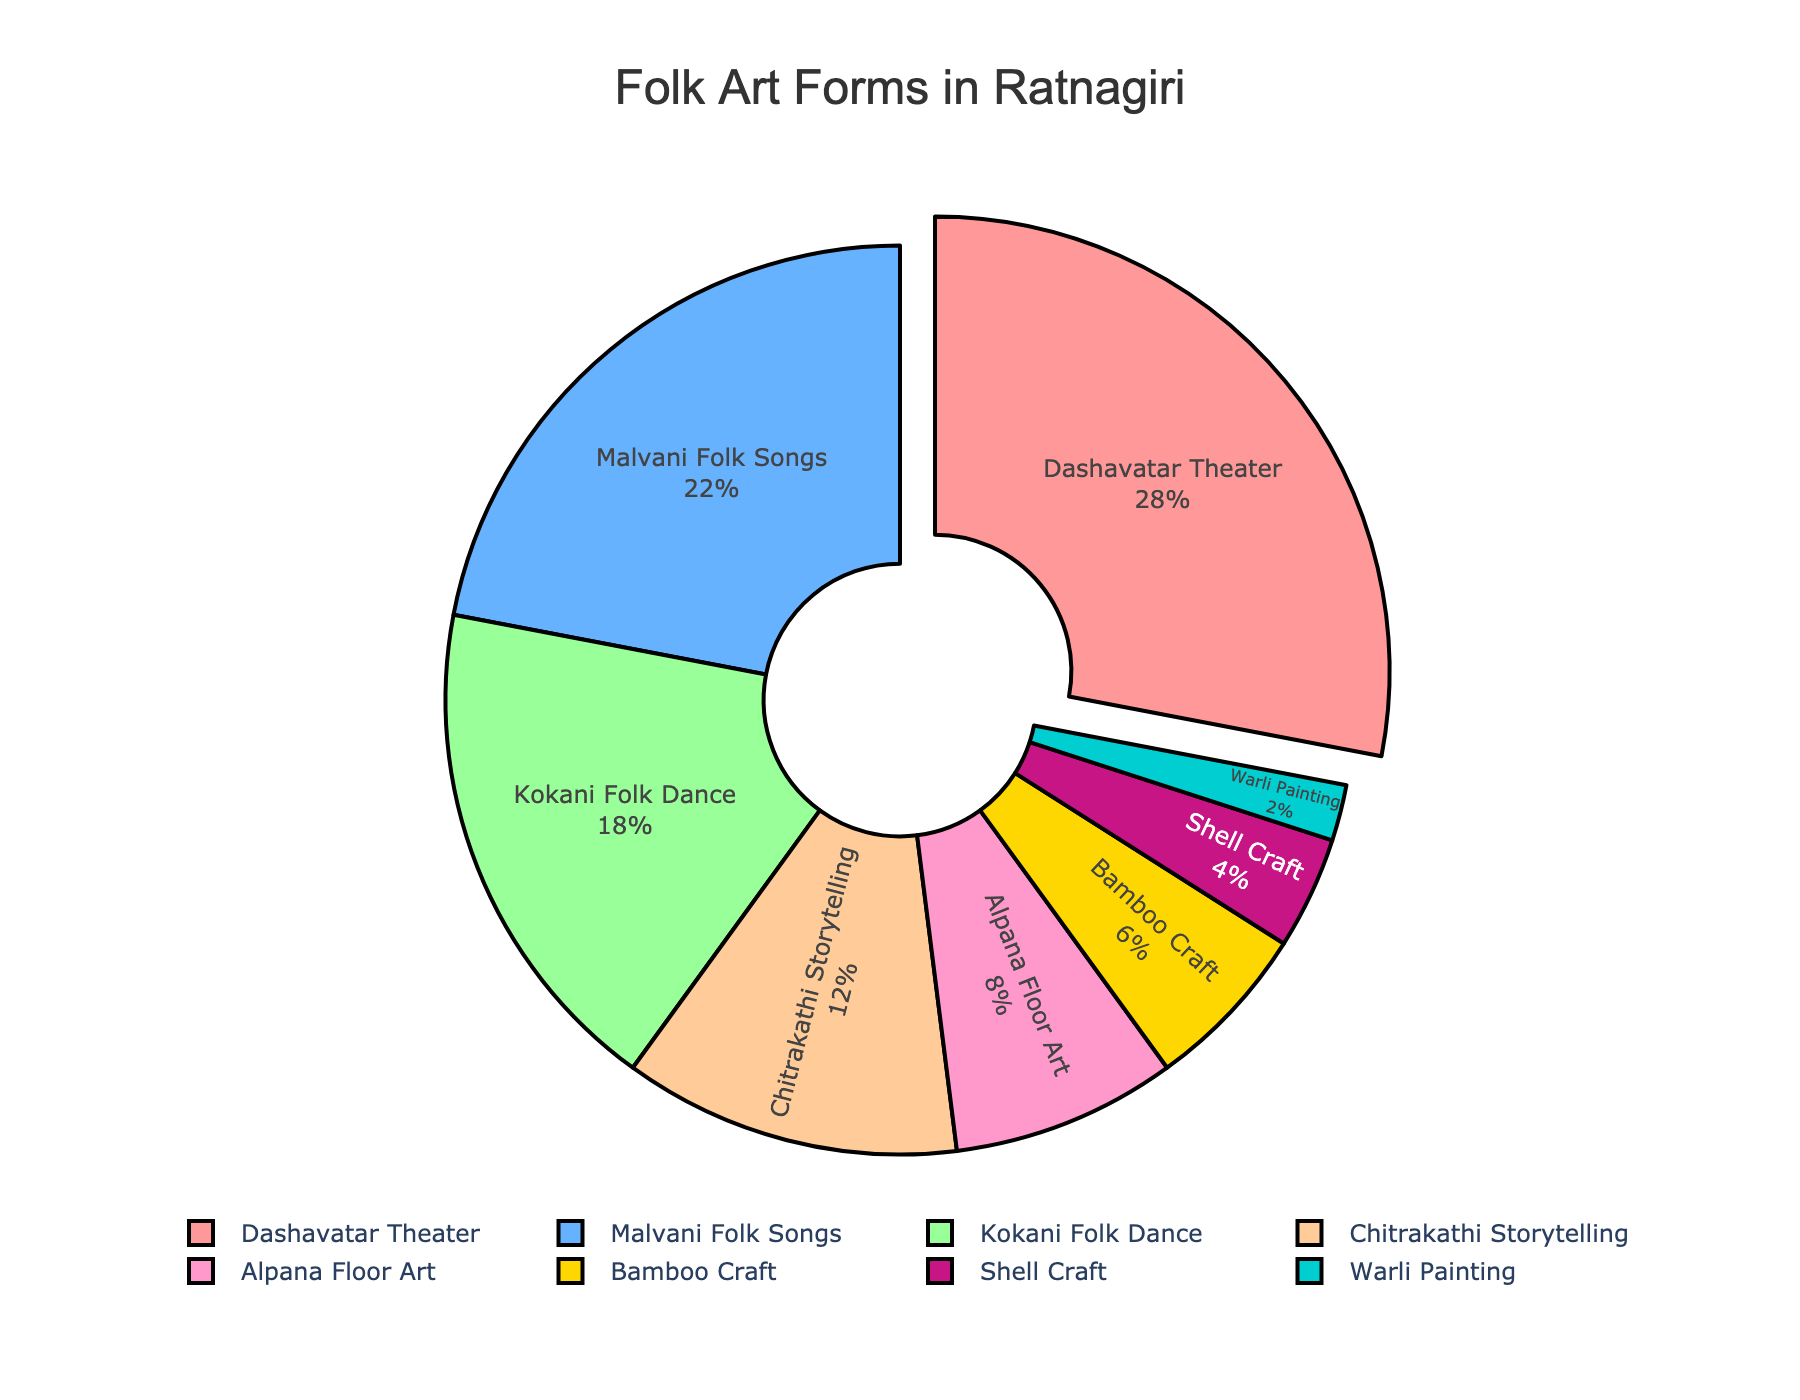What proportion of folk art forms is dedicated to musical expressions? The pie chart shows that Malvani Folk Songs account for 22% of the total folk art forms. Since it's the only musical expression listed, its proportion is 22%.
Answer: 22% Which folk art form has the highest percentage, and how does this compare to the form with the lowest percentage? The chart shows Dashavatar Theater as the highest with 28% and Warli Painting as the lowest with 2%. The difference is 28% - 2% = 26%.
Answer: Dashavatar Theater, 26% If you combine the percentages of Dashavatar Theater and Malvani Folk Songs, what's their total percentage? Dashavatar Theater is 28% and Malvani Folk Songs is 22%. Adding these gives 28% + 22% = 50%.
Answer: 50% What is the combined percentage of all the craft-related art forms? The craft-related art forms in the chart are Bamboo Craft (6%), Shell Craft (4%), and Warli Painting (2%). Summing these gives 6% + 4% + 2% = 12%.
Answer: 12% Which folk art forms have an equal or lower percentage than Chitrakathi Storytelling? Chitrakathi Storytelling is 12%. Comparing other forms: Alpana Floor Art (8%), Bamboo Craft (6%), Shell Craft (4%), and Warli Painting (2%) have equal or lower percentages.
Answer: Alpana Floor Art, Bamboo Craft, Shell Craft, Warli Painting Between Kokani Folk Dance and Chitrakathi Storytelling, which one has a higher percentage and by how much? Kokani Folk Dance is 18% and Chitrakathi Storytelling is 12%. The difference is 18% - 12% = 6%.
Answer: Kokani Folk Dance, 6% What three colors represent the lowest proportions of folk art forms, and what are those proportions? The pie chart shows the proportions and corresponding colors: Warli Painting (2%) in turquoise, Shell Craft (4%) in dark pink, and Bamboo Craft (6%) in yellow.
Answer: Turquoise (2%), Dark pink (4%), Yellow (6%) How much more popular is Dashavatar Theater compared to Alpana Floor Art? Dashavatar Theater is 28% and Alpana Floor Art is 8%. The difference is 28% - 8% = 20%.
Answer: 20% What percentage of the pie chart is represented by storytelling and crafts combined? Chitrakathi Storytelling is 12%, Bamboo Craft is 6%, Shell Craft is 4%, and Warli Painting is 2%. Summing these gives 12% + 6% + 4% + 2% = 24%.
Answer: 24% If we consider adding another art form with a 10% share, how would the new total be calculated? The current total of all art forms is 100%. Adding a new art form with 10% would lead to a new total of 100% + 10% = 110%.
Answer: 110% 